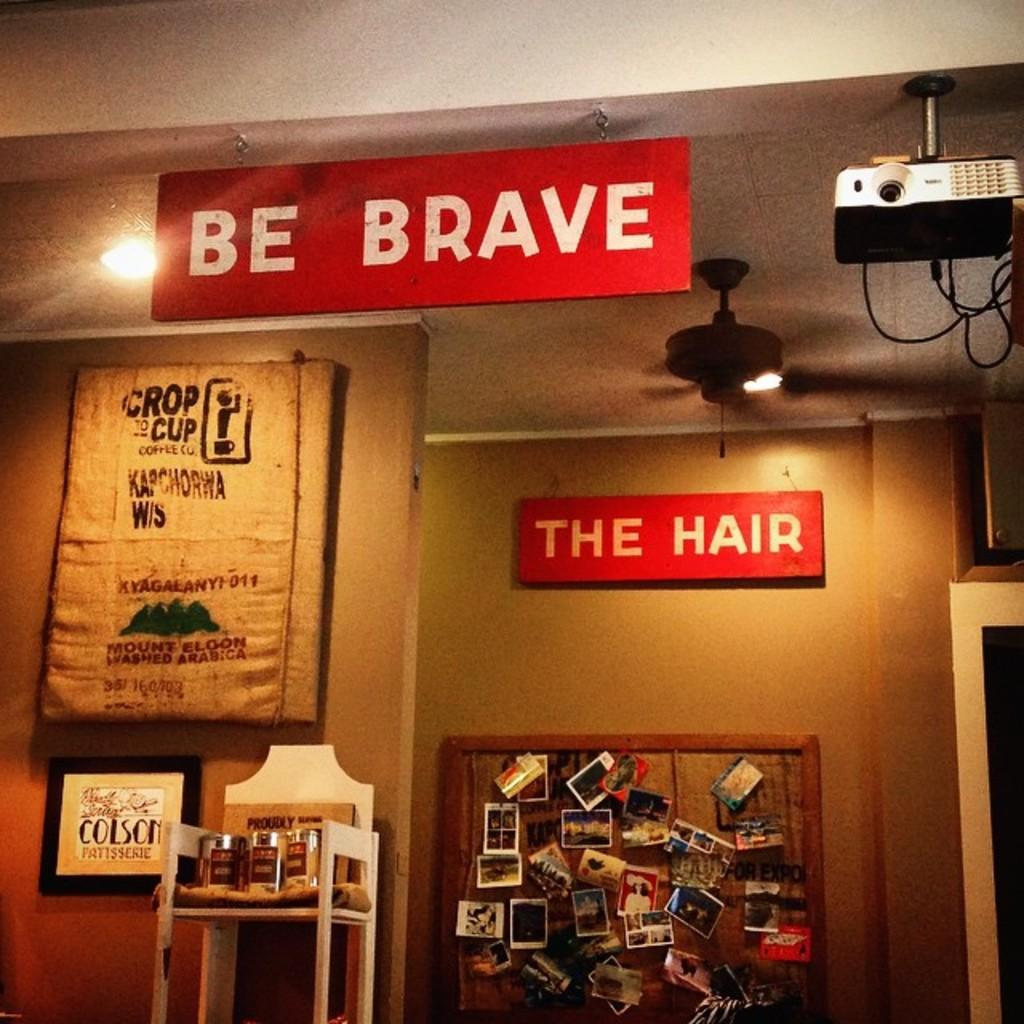<image>
Render a clear and concise summary of the photo. Two red signs are hanging, one says "be brave" and the other says "the hair" 